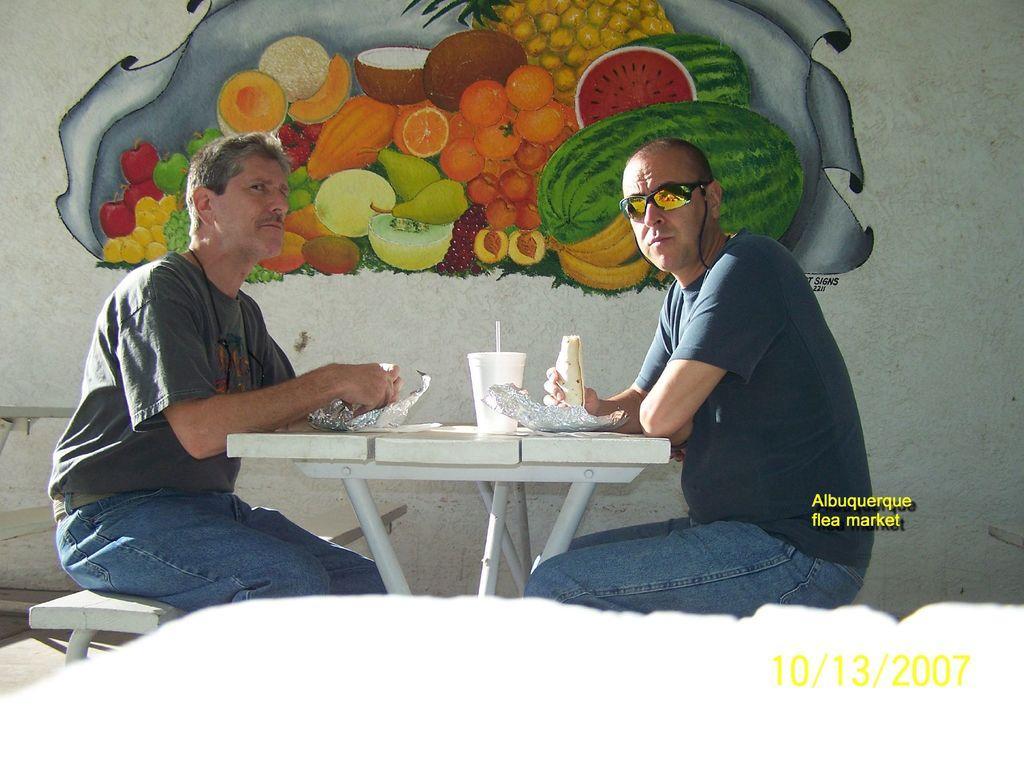In one or two sentences, can you explain what this image depicts? In this picture we can see two men sitting in front of a table, there is a cup present on the table, in the background there is a wall, we can see painting on the wall, there is some text here. 